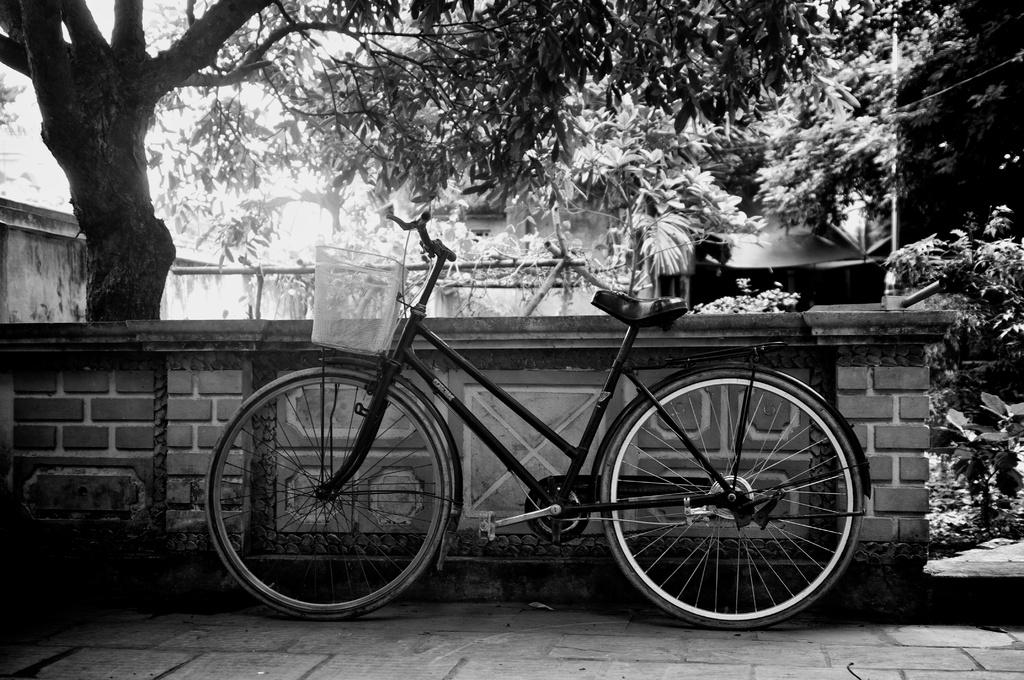What is the main object in the middle of the image? There is a bicycle in the middle of the image. What can be seen in the background of the image? There are trees in the background of the image. What is the color scheme of the image? The image is black and white. Where is the crown placed on the bicycle in the image? There is no crown present on the bicycle in the image. Is there a spy observing the bicycle in the image? There is no indication of a spy or any person in the image; it only features a bicycle and trees in the background. 